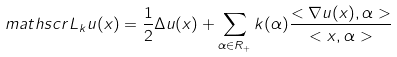<formula> <loc_0><loc_0><loc_500><loc_500>\ m a t h s c r { L } _ { k } u ( x ) = \frac { 1 } { 2 } \Delta u ( x ) + \sum _ { \alpha \in R _ { + } } k ( \alpha ) \frac { < \nabla u ( x ) , \alpha > } { < x , \alpha > }</formula> 